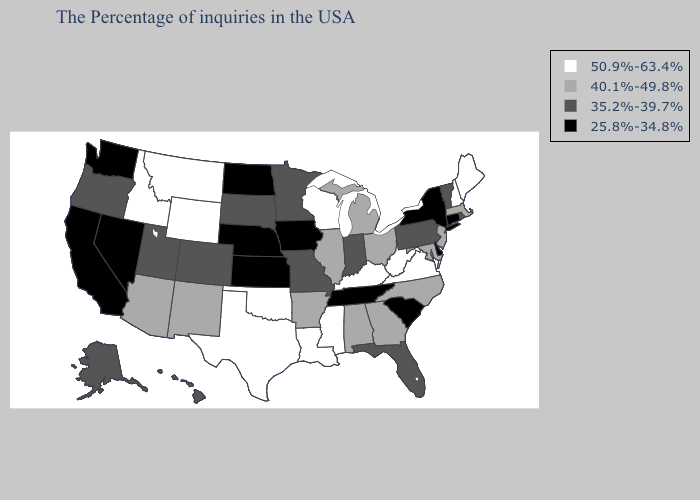Name the states that have a value in the range 40.1%-49.8%?
Write a very short answer. Massachusetts, New Jersey, Maryland, North Carolina, Ohio, Georgia, Michigan, Alabama, Illinois, Arkansas, New Mexico, Arizona. Which states have the lowest value in the South?
Quick response, please. Delaware, South Carolina, Tennessee. Among the states that border Illinois , which have the lowest value?
Answer briefly. Iowa. Among the states that border Florida , which have the highest value?
Answer briefly. Georgia, Alabama. Does North Carolina have a higher value than Massachusetts?
Give a very brief answer. No. Which states hav the highest value in the South?
Write a very short answer. Virginia, West Virginia, Kentucky, Mississippi, Louisiana, Oklahoma, Texas. Is the legend a continuous bar?
Be succinct. No. What is the value of Idaho?
Keep it brief. 50.9%-63.4%. Name the states that have a value in the range 40.1%-49.8%?
Keep it brief. Massachusetts, New Jersey, Maryland, North Carolina, Ohio, Georgia, Michigan, Alabama, Illinois, Arkansas, New Mexico, Arizona. What is the value of Wisconsin?
Write a very short answer. 50.9%-63.4%. What is the value of Connecticut?
Quick response, please. 25.8%-34.8%. Which states have the lowest value in the USA?
Write a very short answer. Connecticut, New York, Delaware, South Carolina, Tennessee, Iowa, Kansas, Nebraska, North Dakota, Nevada, California, Washington. Name the states that have a value in the range 25.8%-34.8%?
Quick response, please. Connecticut, New York, Delaware, South Carolina, Tennessee, Iowa, Kansas, Nebraska, North Dakota, Nevada, California, Washington. Does Maine have the highest value in the Northeast?
Answer briefly. Yes. Name the states that have a value in the range 40.1%-49.8%?
Give a very brief answer. Massachusetts, New Jersey, Maryland, North Carolina, Ohio, Georgia, Michigan, Alabama, Illinois, Arkansas, New Mexico, Arizona. 